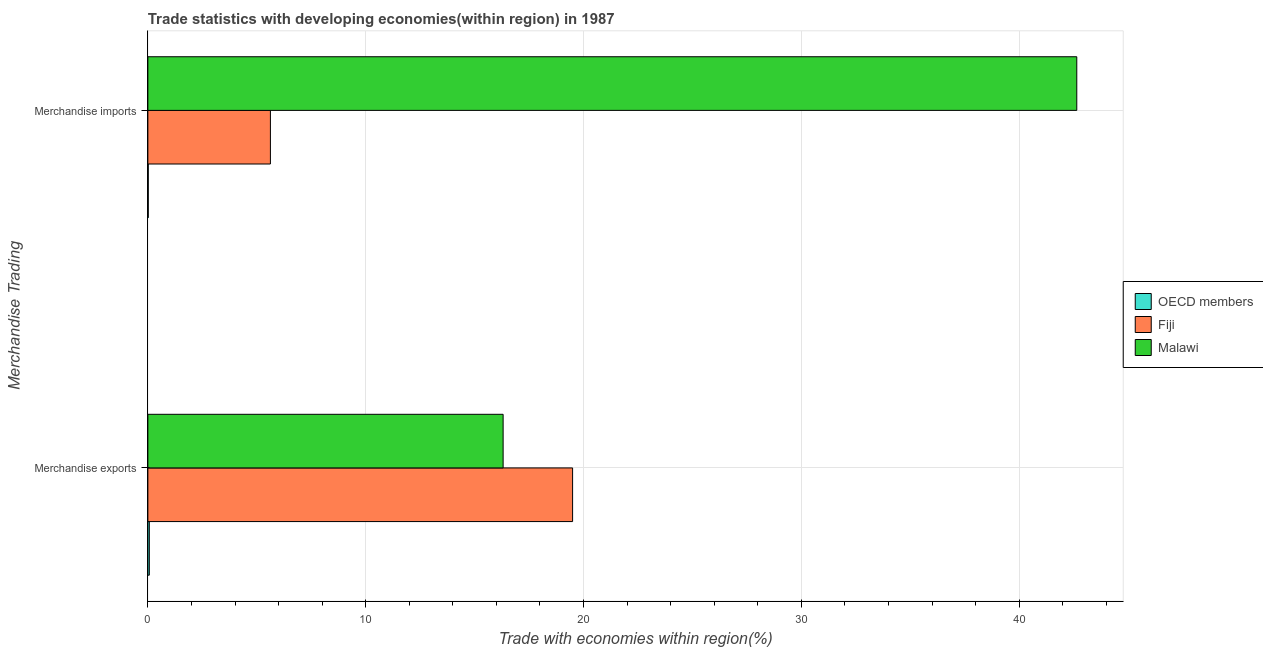How many different coloured bars are there?
Your answer should be compact. 3. Are the number of bars per tick equal to the number of legend labels?
Keep it short and to the point. Yes. What is the label of the 2nd group of bars from the top?
Offer a very short reply. Merchandise exports. What is the merchandise exports in OECD members?
Offer a very short reply. 0.07. Across all countries, what is the maximum merchandise imports?
Provide a succinct answer. 42.64. Across all countries, what is the minimum merchandise imports?
Keep it short and to the point. 0.02. In which country was the merchandise imports maximum?
Provide a succinct answer. Malawi. In which country was the merchandise exports minimum?
Provide a succinct answer. OECD members. What is the total merchandise imports in the graph?
Ensure brevity in your answer.  48.29. What is the difference between the merchandise imports in Malawi and that in Fiji?
Keep it short and to the point. 37.02. What is the difference between the merchandise exports in OECD members and the merchandise imports in Malawi?
Provide a succinct answer. -42.58. What is the average merchandise imports per country?
Your answer should be compact. 16.1. What is the difference between the merchandise imports and merchandise exports in Malawi?
Provide a succinct answer. 26.34. In how many countries, is the merchandise exports greater than 14 %?
Give a very brief answer. 2. What is the ratio of the merchandise exports in OECD members to that in Fiji?
Keep it short and to the point. 0. In how many countries, is the merchandise exports greater than the average merchandise exports taken over all countries?
Your answer should be compact. 2. What does the 3rd bar from the bottom in Merchandise exports represents?
Keep it short and to the point. Malawi. How many bars are there?
Keep it short and to the point. 6. Are all the bars in the graph horizontal?
Offer a terse response. Yes. How many countries are there in the graph?
Offer a very short reply. 3. What is the difference between two consecutive major ticks on the X-axis?
Provide a succinct answer. 10. Are the values on the major ticks of X-axis written in scientific E-notation?
Offer a very short reply. No. Does the graph contain any zero values?
Offer a very short reply. No. Does the graph contain grids?
Give a very brief answer. Yes. What is the title of the graph?
Ensure brevity in your answer.  Trade statistics with developing economies(within region) in 1987. What is the label or title of the X-axis?
Your answer should be compact. Trade with economies within region(%). What is the label or title of the Y-axis?
Give a very brief answer. Merchandise Trading. What is the Trade with economies within region(%) of OECD members in Merchandise exports?
Offer a very short reply. 0.07. What is the Trade with economies within region(%) of Fiji in Merchandise exports?
Provide a succinct answer. 19.5. What is the Trade with economies within region(%) of Malawi in Merchandise exports?
Provide a succinct answer. 16.31. What is the Trade with economies within region(%) in OECD members in Merchandise imports?
Provide a short and direct response. 0.02. What is the Trade with economies within region(%) of Fiji in Merchandise imports?
Give a very brief answer. 5.63. What is the Trade with economies within region(%) in Malawi in Merchandise imports?
Keep it short and to the point. 42.64. Across all Merchandise Trading, what is the maximum Trade with economies within region(%) of OECD members?
Ensure brevity in your answer.  0.07. Across all Merchandise Trading, what is the maximum Trade with economies within region(%) in Fiji?
Make the answer very short. 19.5. Across all Merchandise Trading, what is the maximum Trade with economies within region(%) of Malawi?
Give a very brief answer. 42.64. Across all Merchandise Trading, what is the minimum Trade with economies within region(%) of OECD members?
Give a very brief answer. 0.02. Across all Merchandise Trading, what is the minimum Trade with economies within region(%) of Fiji?
Provide a succinct answer. 5.63. Across all Merchandise Trading, what is the minimum Trade with economies within region(%) of Malawi?
Provide a short and direct response. 16.31. What is the total Trade with economies within region(%) in OECD members in the graph?
Offer a terse response. 0.08. What is the total Trade with economies within region(%) of Fiji in the graph?
Offer a terse response. 25.12. What is the total Trade with economies within region(%) in Malawi in the graph?
Keep it short and to the point. 58.95. What is the difference between the Trade with economies within region(%) in OECD members in Merchandise exports and that in Merchandise imports?
Offer a terse response. 0.05. What is the difference between the Trade with economies within region(%) of Fiji in Merchandise exports and that in Merchandise imports?
Your answer should be very brief. 13.87. What is the difference between the Trade with economies within region(%) of Malawi in Merchandise exports and that in Merchandise imports?
Your answer should be compact. -26.34. What is the difference between the Trade with economies within region(%) in OECD members in Merchandise exports and the Trade with economies within region(%) in Fiji in Merchandise imports?
Give a very brief answer. -5.56. What is the difference between the Trade with economies within region(%) in OECD members in Merchandise exports and the Trade with economies within region(%) in Malawi in Merchandise imports?
Provide a short and direct response. -42.58. What is the difference between the Trade with economies within region(%) in Fiji in Merchandise exports and the Trade with economies within region(%) in Malawi in Merchandise imports?
Provide a short and direct response. -23.15. What is the average Trade with economies within region(%) of OECD members per Merchandise Trading?
Offer a terse response. 0.04. What is the average Trade with economies within region(%) of Fiji per Merchandise Trading?
Ensure brevity in your answer.  12.56. What is the average Trade with economies within region(%) of Malawi per Merchandise Trading?
Your answer should be compact. 29.48. What is the difference between the Trade with economies within region(%) in OECD members and Trade with economies within region(%) in Fiji in Merchandise exports?
Keep it short and to the point. -19.43. What is the difference between the Trade with economies within region(%) in OECD members and Trade with economies within region(%) in Malawi in Merchandise exports?
Keep it short and to the point. -16.24. What is the difference between the Trade with economies within region(%) in Fiji and Trade with economies within region(%) in Malawi in Merchandise exports?
Provide a succinct answer. 3.19. What is the difference between the Trade with economies within region(%) in OECD members and Trade with economies within region(%) in Fiji in Merchandise imports?
Your answer should be compact. -5.61. What is the difference between the Trade with economies within region(%) of OECD members and Trade with economies within region(%) of Malawi in Merchandise imports?
Ensure brevity in your answer.  -42.63. What is the difference between the Trade with economies within region(%) of Fiji and Trade with economies within region(%) of Malawi in Merchandise imports?
Your answer should be compact. -37.02. What is the ratio of the Trade with economies within region(%) in OECD members in Merchandise exports to that in Merchandise imports?
Your answer should be compact. 3.69. What is the ratio of the Trade with economies within region(%) in Fiji in Merchandise exports to that in Merchandise imports?
Ensure brevity in your answer.  3.47. What is the ratio of the Trade with economies within region(%) in Malawi in Merchandise exports to that in Merchandise imports?
Make the answer very short. 0.38. What is the difference between the highest and the second highest Trade with economies within region(%) in OECD members?
Keep it short and to the point. 0.05. What is the difference between the highest and the second highest Trade with economies within region(%) of Fiji?
Offer a very short reply. 13.87. What is the difference between the highest and the second highest Trade with economies within region(%) of Malawi?
Keep it short and to the point. 26.34. What is the difference between the highest and the lowest Trade with economies within region(%) of OECD members?
Your response must be concise. 0.05. What is the difference between the highest and the lowest Trade with economies within region(%) of Fiji?
Offer a very short reply. 13.87. What is the difference between the highest and the lowest Trade with economies within region(%) of Malawi?
Provide a succinct answer. 26.34. 